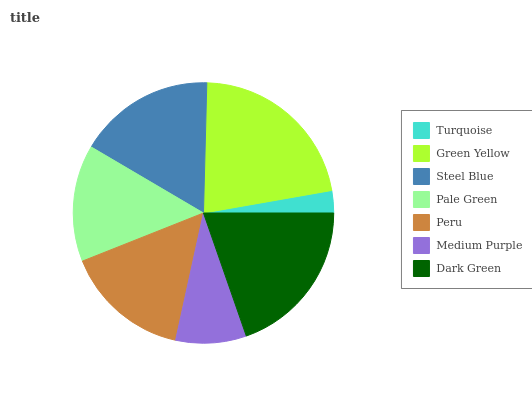Is Turquoise the minimum?
Answer yes or no. Yes. Is Green Yellow the maximum?
Answer yes or no. Yes. Is Steel Blue the minimum?
Answer yes or no. No. Is Steel Blue the maximum?
Answer yes or no. No. Is Green Yellow greater than Steel Blue?
Answer yes or no. Yes. Is Steel Blue less than Green Yellow?
Answer yes or no. Yes. Is Steel Blue greater than Green Yellow?
Answer yes or no. No. Is Green Yellow less than Steel Blue?
Answer yes or no. No. Is Peru the high median?
Answer yes or no. Yes. Is Peru the low median?
Answer yes or no. Yes. Is Medium Purple the high median?
Answer yes or no. No. Is Pale Green the low median?
Answer yes or no. No. 